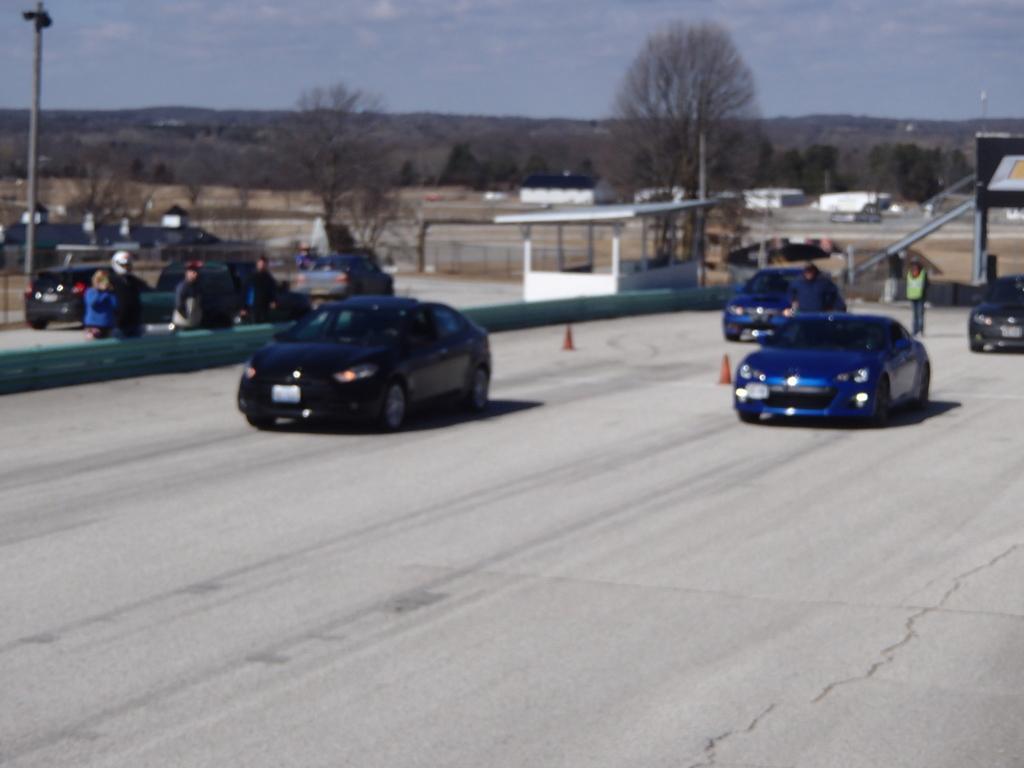Please provide a concise description of this image. In this picture we can see vehicles on the road and in the background we can see trees,sky. 